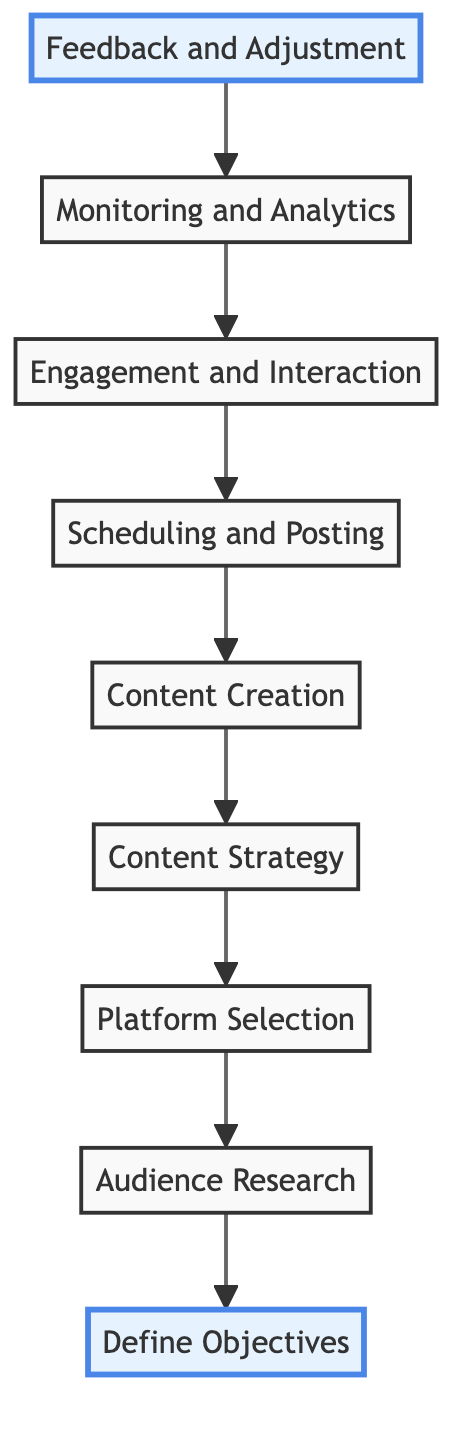What is the first step in the process? The flow chart indicates that the first step is "Define Objectives," as it's the bottom node that initiates the outreach process.
Answer: Define Objectives How many steps are there in total? By counting the nodes in the flow chart, there are nine distinct steps listed, from "Define Objectives" to "Feedback and Adjustment."
Answer: 9 Which step comes after "Engagement and Interaction"? From the flow chart, "Monitoring and Analytics" comes directly after "Engagement and Interaction," as it is positioned higher in the flow.
Answer: Monitoring and Analytics What is the final step of the process? The diagram shows that the final step is "Define Objectives," which is the top node in the upward flow of the process.
Answer: Feedback and Adjustment Which node follows "Content Creation"? According to the diagram, "Scheduling and Posting" directly follows "Content Creation" in the flow sequence.
Answer: Scheduling and Posting Where does the "Platform Selection" fit in the sequence? "Platform Selection" is shown as the sixth step in the flow chart, coming before "Content Strategy" and after "Audience Research."
Answer: Sixth How does "Audience Research" relate to "Define Objectives"? "Audience Research" is directly linked to "Define Objectives," as it informs and supports the goals set out in that initial step.
Answer: Inform and support What action is taken after "Feedback and Adjustment"? Following "Feedback and Adjustment," there are no additional actions outlined in the flow chart, indicating that it is the concluding step of the process.
Answer: None What is a tool mentioned for "Scheduling and Posting"? The flow chart specifies tools such as "Hootsuite" and "Buffer" for the scheduling and posting step.
Answer: Hootsuite, Buffer 